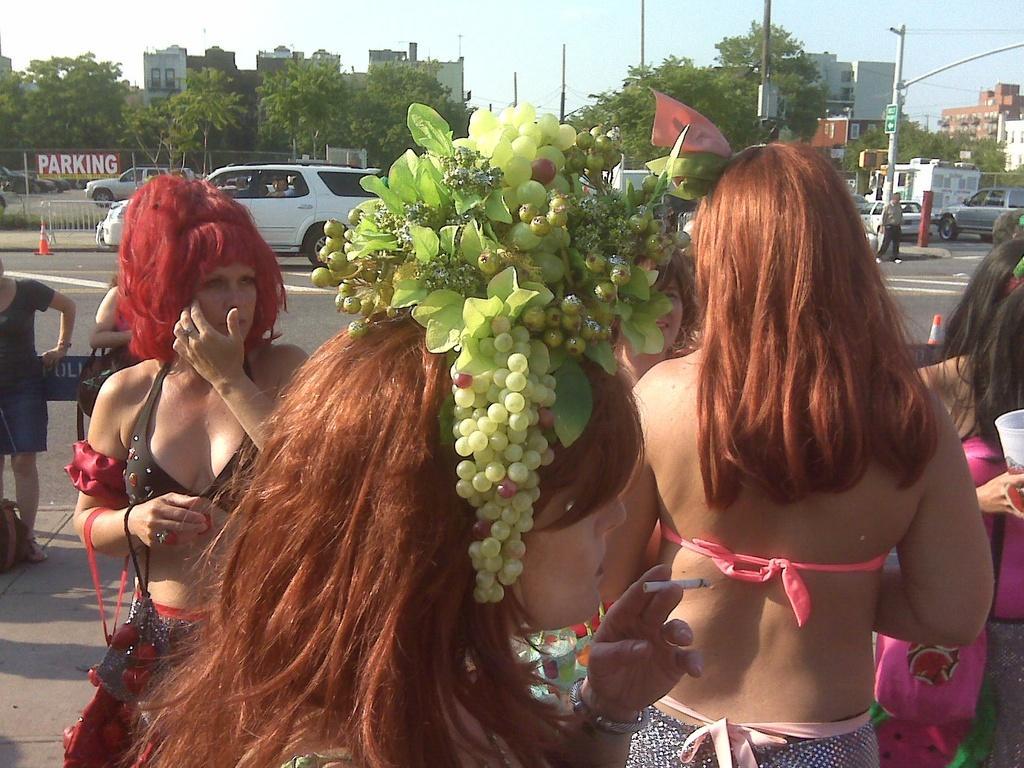Describe this image in one or two sentences. This is the picture of the road. There are group of people standing on the road. At the back there are vehicles, buildings, trees and poles. 